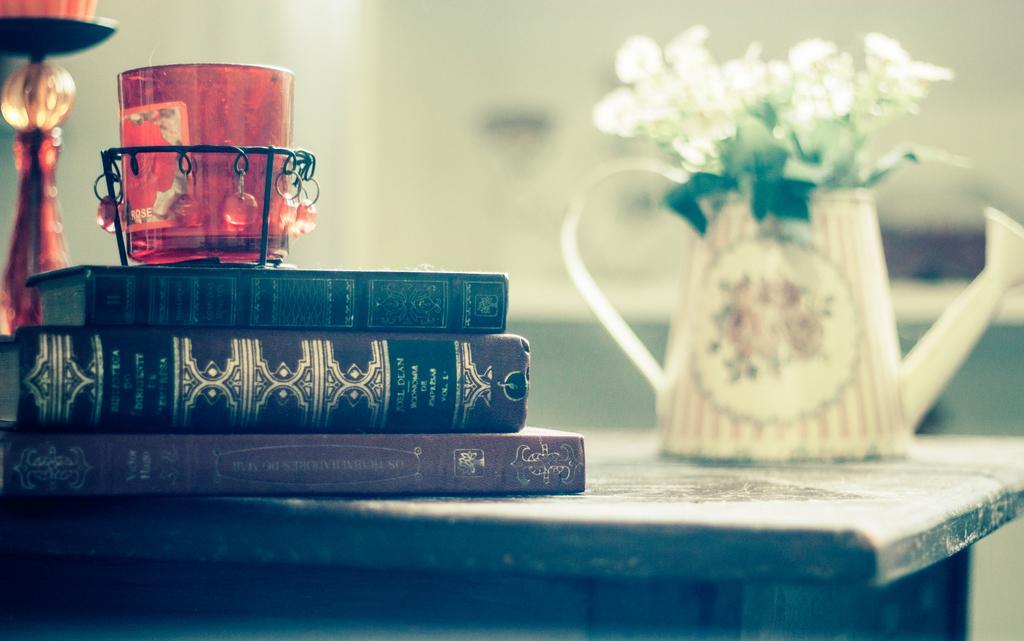Please provide a concise description of this image. In this picture we can see a decorative glass, dairies, candle stand and a flower vase on the table. 